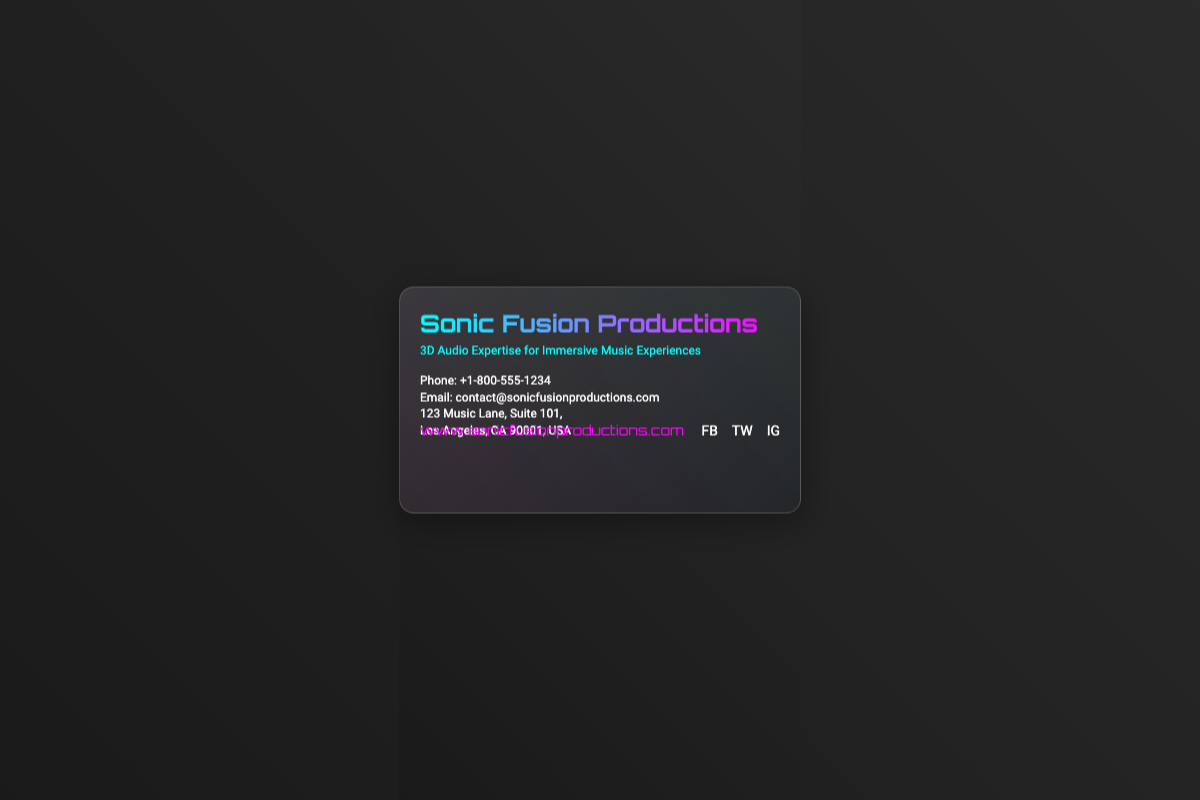What is the name of the company? The company name is displayed prominently at the top of the card.
Answer: Sonic Fusion Productions What is the tagline of the business? The tagline describes their specialized service and is found below the company name.
Answer: 3D Audio Expertise for Immersive Music Experiences What is the phone number listed? The phone number is provided in the contact information section of the card.
Answer: +1-800-555-1234 What is the email address for contact? The email is specified in the contact details on the card.
Answer: contact@sonicfusionproductions.com Where is the company located? The address is listed in the contact details, providing location information.
Answer: 123 Music Lane, Suite 101, Los Angeles, CA 90001, USA Which social media platforms are linked? The social icons at the bottom indicate the social media platforms the business is active on.
Answer: Facebook, Twitter, Instagram What type of audio expertise does the company provide? The tagline mentions the specific type of expertise offered by the company.
Answer: 3D Audio What visual effect is used on the business card? The background includes a specific effect mentioned in the design description.
Answer: Holographic visual effect What is the website of Sonic Fusion Productions? The website is clearly stated in the contact section of the card.
Answer: www.sonicfusionproductions.com What is the purpose of the QR code on the card? While not explicitly stated, the QR code typically links to more information or a website.
Answer: More information or website link 